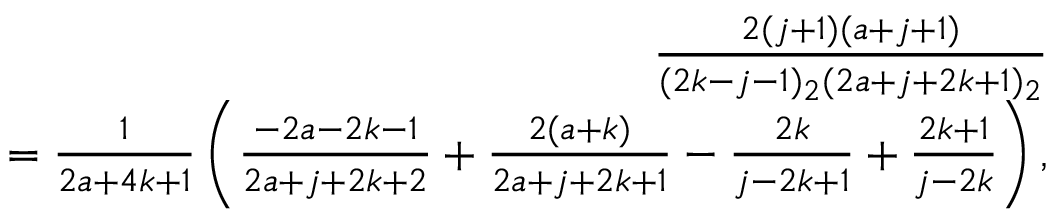<formula> <loc_0><loc_0><loc_500><loc_500>\begin{array} { r } { \, \frac { 2 ( j + 1 ) ( a + j + 1 ) } { ( 2 k - j - 1 ) _ { 2 } ( 2 a + j + 2 k + 1 ) _ { 2 } } } \\ { \, = \frac { 1 } { 2 a + 4 k + 1 } \left ( \frac { - 2 a - 2 k - 1 } { 2 a + j + 2 k + 2 } + \frac { 2 ( a + k ) } { 2 a + j + 2 k + 1 } - \frac { 2 k } { j - 2 k + 1 } + \frac { 2 k + 1 } { j - 2 k } \right ) , } \end{array}</formula> 